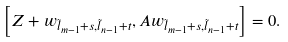<formula> <loc_0><loc_0><loc_500><loc_500>\left [ Z + w _ { \tilde { l } _ { m - 1 } + s , \tilde { l } _ { n - 1 } + t } , A w _ { \tilde { l } _ { m - 1 } + s , \tilde { l } _ { n - 1 } + t } \right ] = 0 .</formula> 